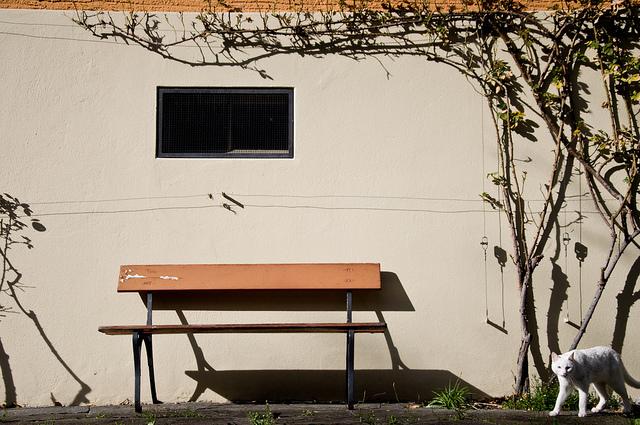Is there a window?
Keep it brief. Yes. What color is the wall?
Short answer required. White. What animal is standing by the bench?
Concise answer only. Cat. 